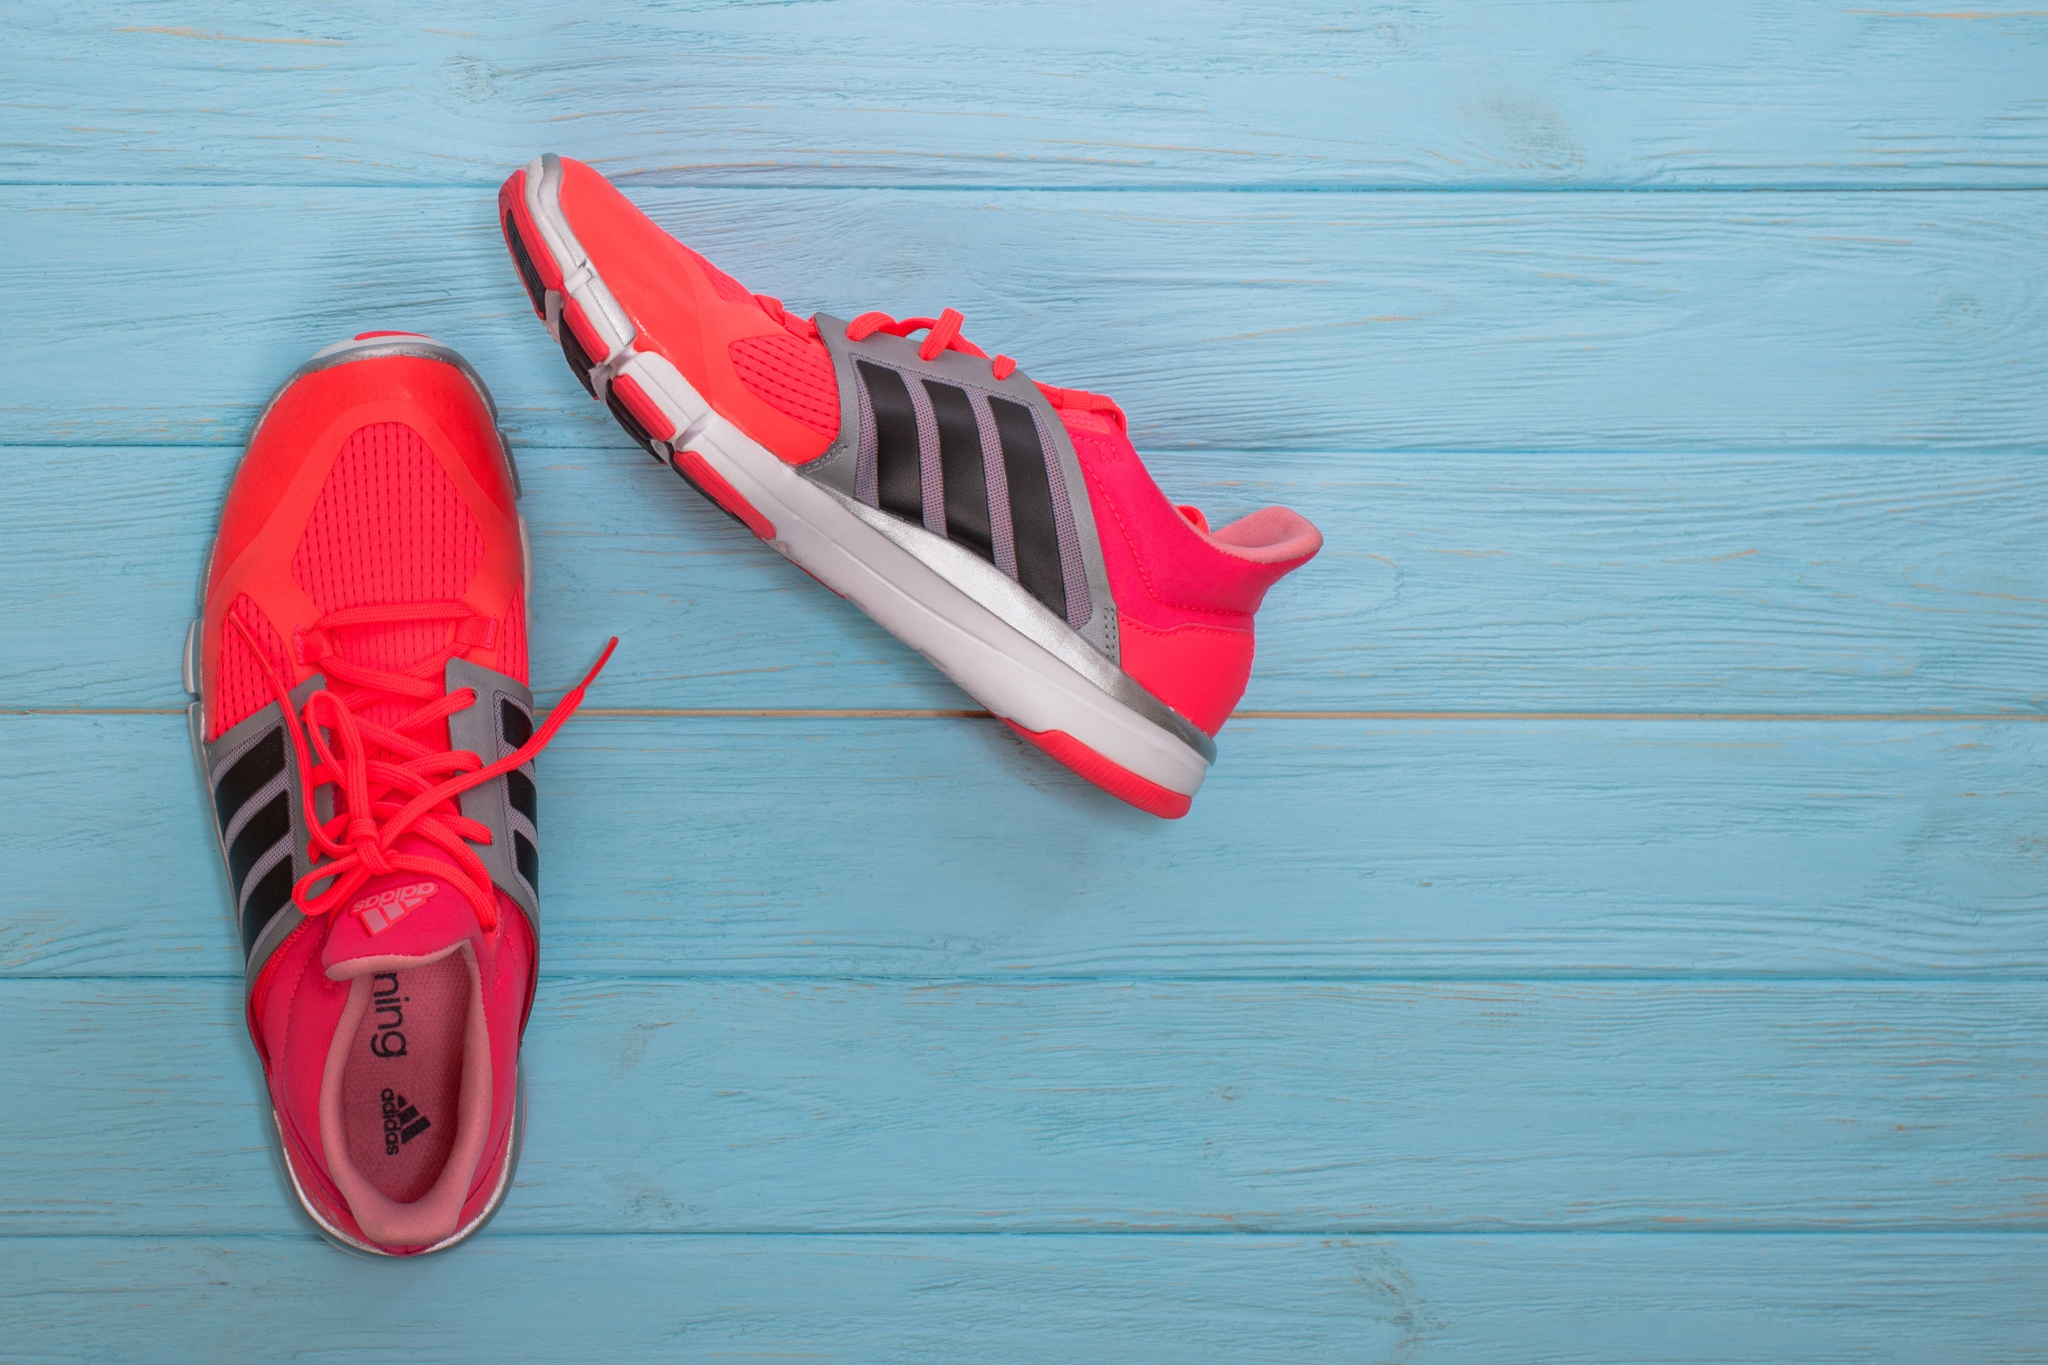What do you see happening in this image? The image portrays a pair of Adidas running shoes, dynamically arranged against a textured blue wooden backdrop. One shoe lies flat while the other is angled slightly away, creating a playful and visually striking composition. The shoes boast a vivid red color accented by bold black Adidas stripes on the side, with matching red laces that add an extra burst of color. The blue wooden planks beneath the shoes lend a rustic and serene contrast to the vibrant footwear, making the red and black colors pop even more. The entire setup is captured from a high angle, offering a comprehensive view of the scene. 